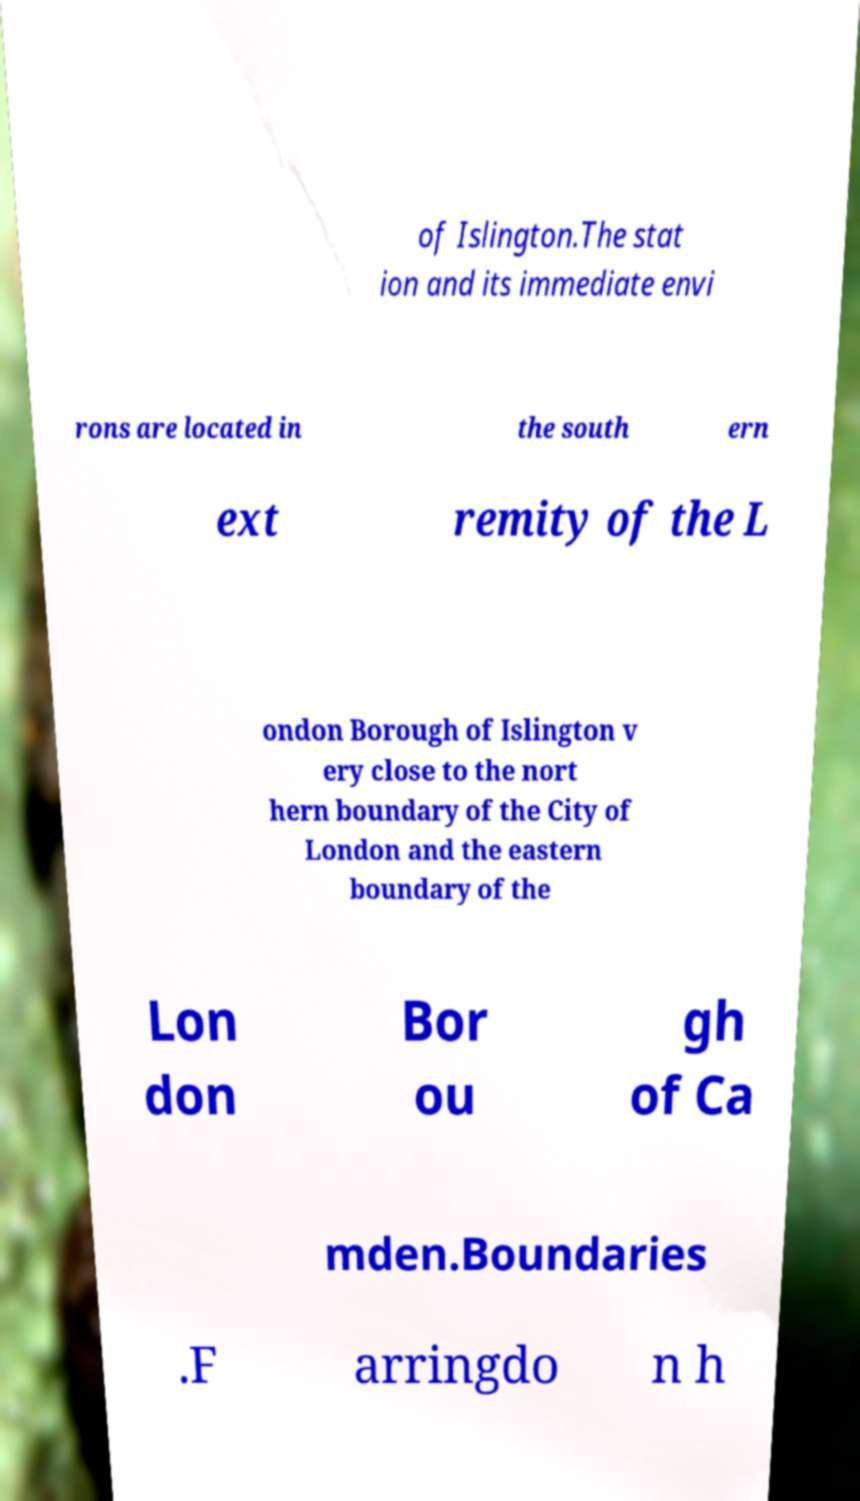For documentation purposes, I need the text within this image transcribed. Could you provide that? of Islington.The stat ion and its immediate envi rons are located in the south ern ext remity of the L ondon Borough of Islington v ery close to the nort hern boundary of the City of London and the eastern boundary of the Lon don Bor ou gh of Ca mden.Boundaries .F arringdo n h 